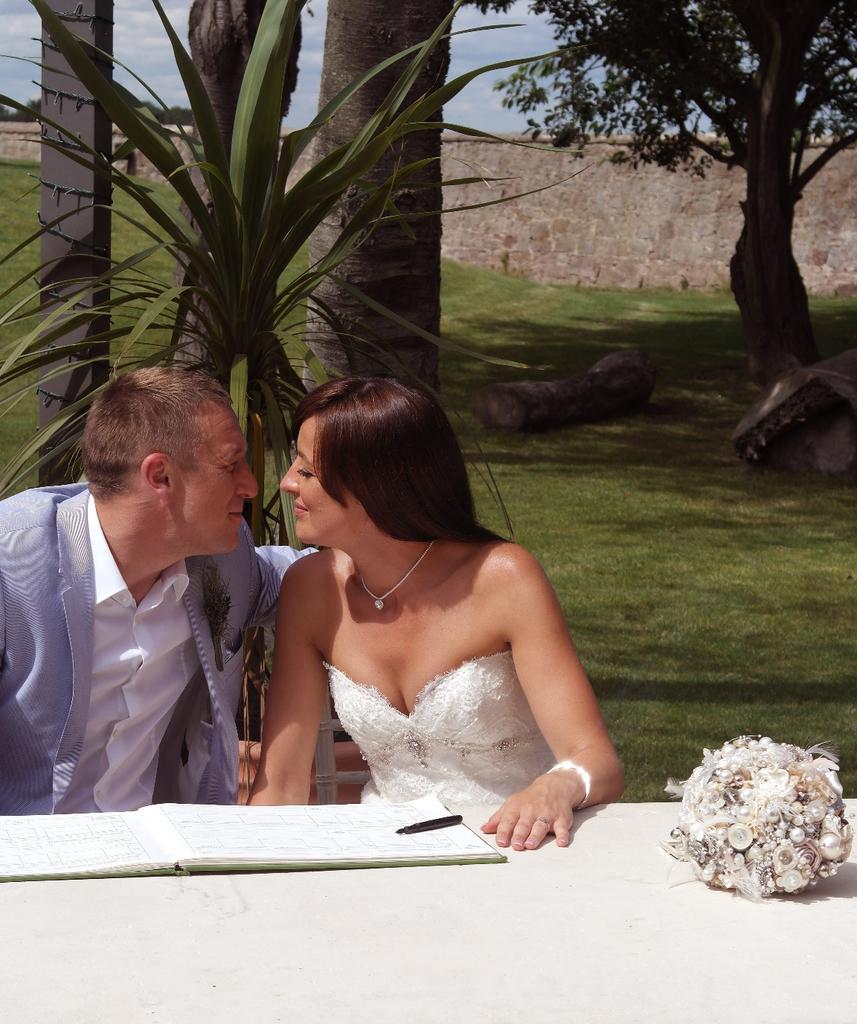Describe this image in one or two sentences. In this picture I can see there is a man and a woman sitting at the table and they are smiling and there is a book in front of them and the man is wearing a blazer and the woman is wearing a white dress and in the backdrop there is a wall, plants and trees. The sky is clear. 